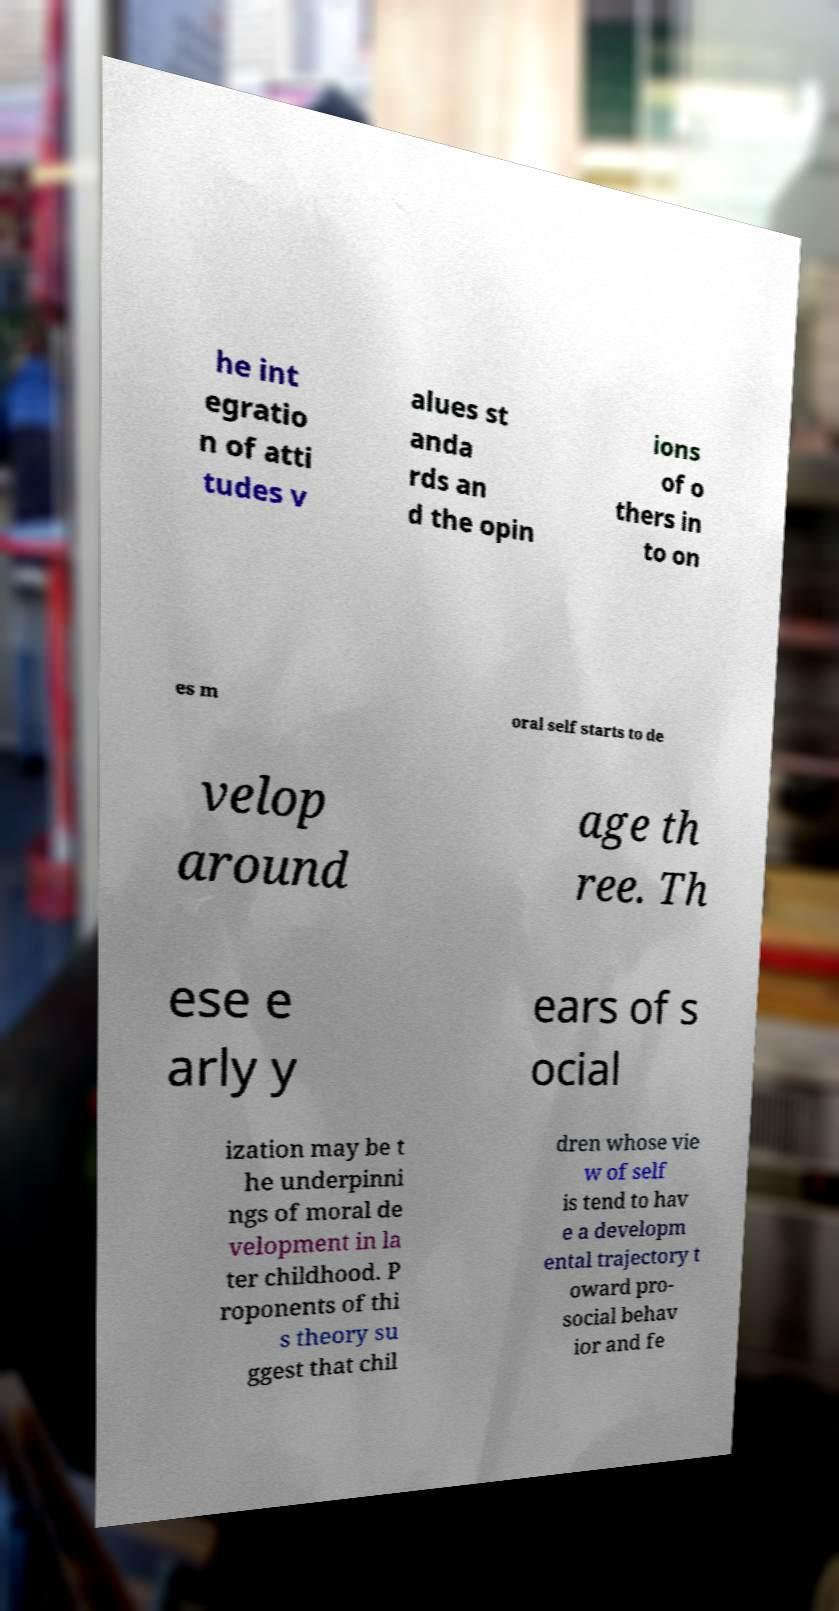Please read and relay the text visible in this image. What does it say? he int egratio n of atti tudes v alues st anda rds an d the opin ions of o thers in to on es m oral self starts to de velop around age th ree. Th ese e arly y ears of s ocial ization may be t he underpinni ngs of moral de velopment in la ter childhood. P roponents of thi s theory su ggest that chil dren whose vie w of self is tend to hav e a developm ental trajectory t oward pro- social behav ior and fe 